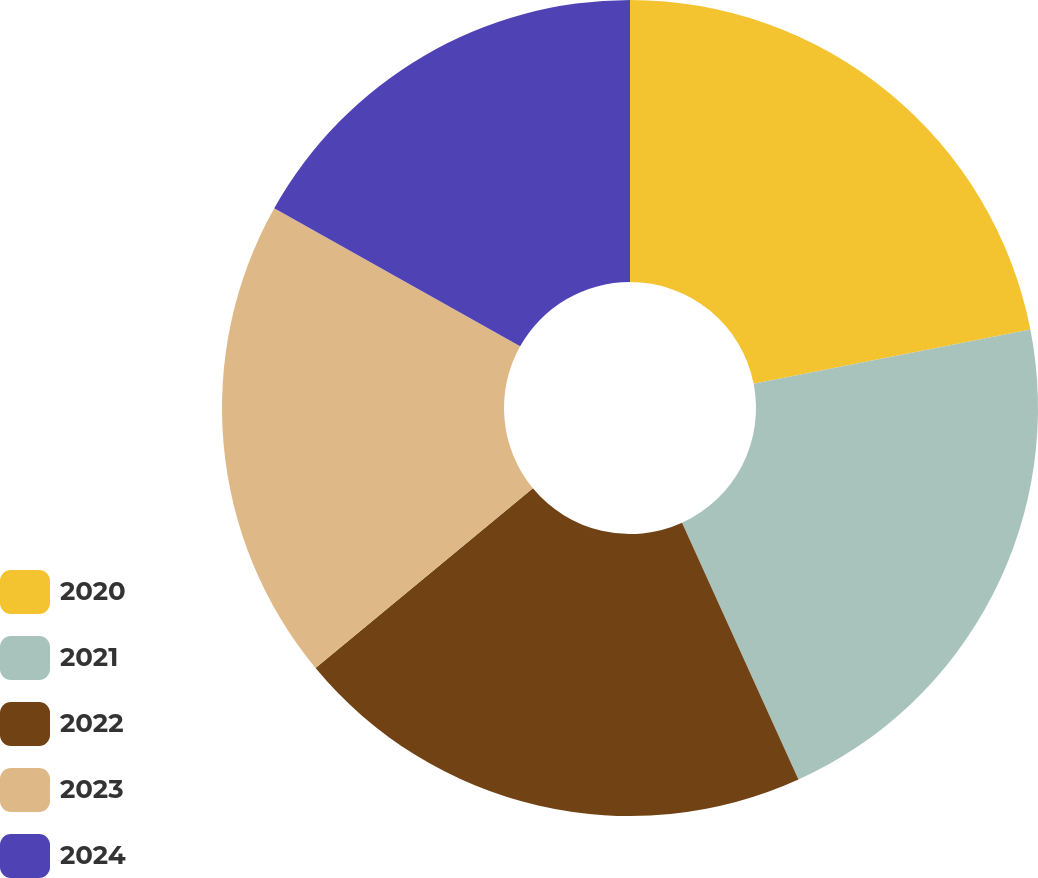<chart> <loc_0><loc_0><loc_500><loc_500><pie_chart><fcel>2020<fcel>2021<fcel>2022<fcel>2023<fcel>2024<nl><fcel>21.92%<fcel>21.31%<fcel>20.78%<fcel>19.14%<fcel>16.86%<nl></chart> 